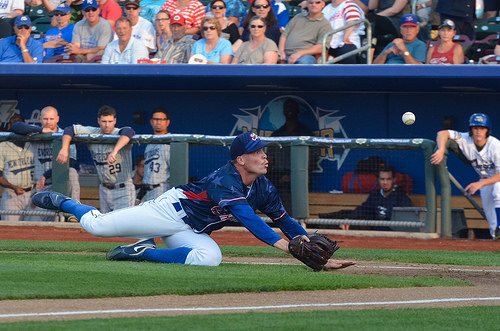<image>
Can you confirm if the player is in the dugout? Yes. The player is contained within or inside the dugout, showing a containment relationship. Where is the dugout in relation to the man? Is it behind the man? Yes. From this viewpoint, the dugout is positioned behind the man, with the man partially or fully occluding the dugout. Is there a baseball behind the baseball mitt? No. The baseball is not behind the baseball mitt. From this viewpoint, the baseball appears to be positioned elsewhere in the scene. 